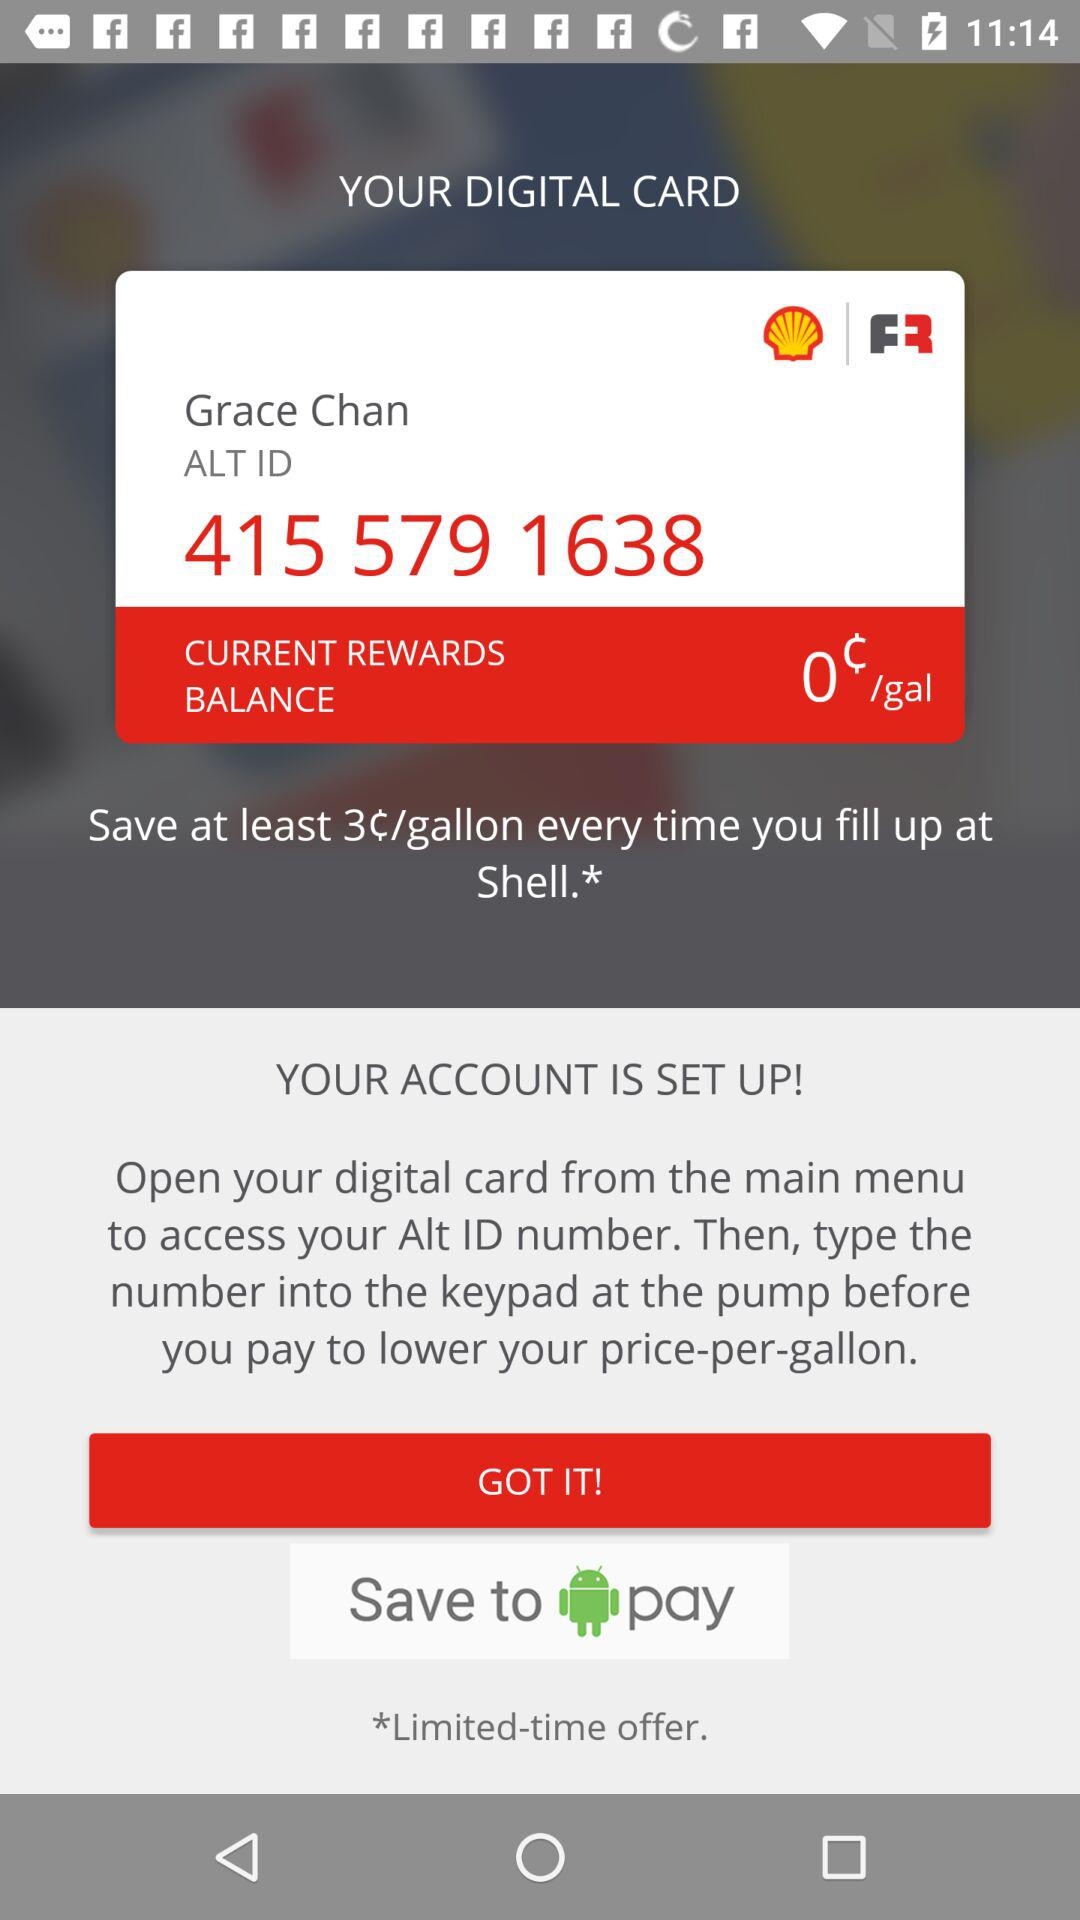What is the name on the card? The name is Grace Chan. 